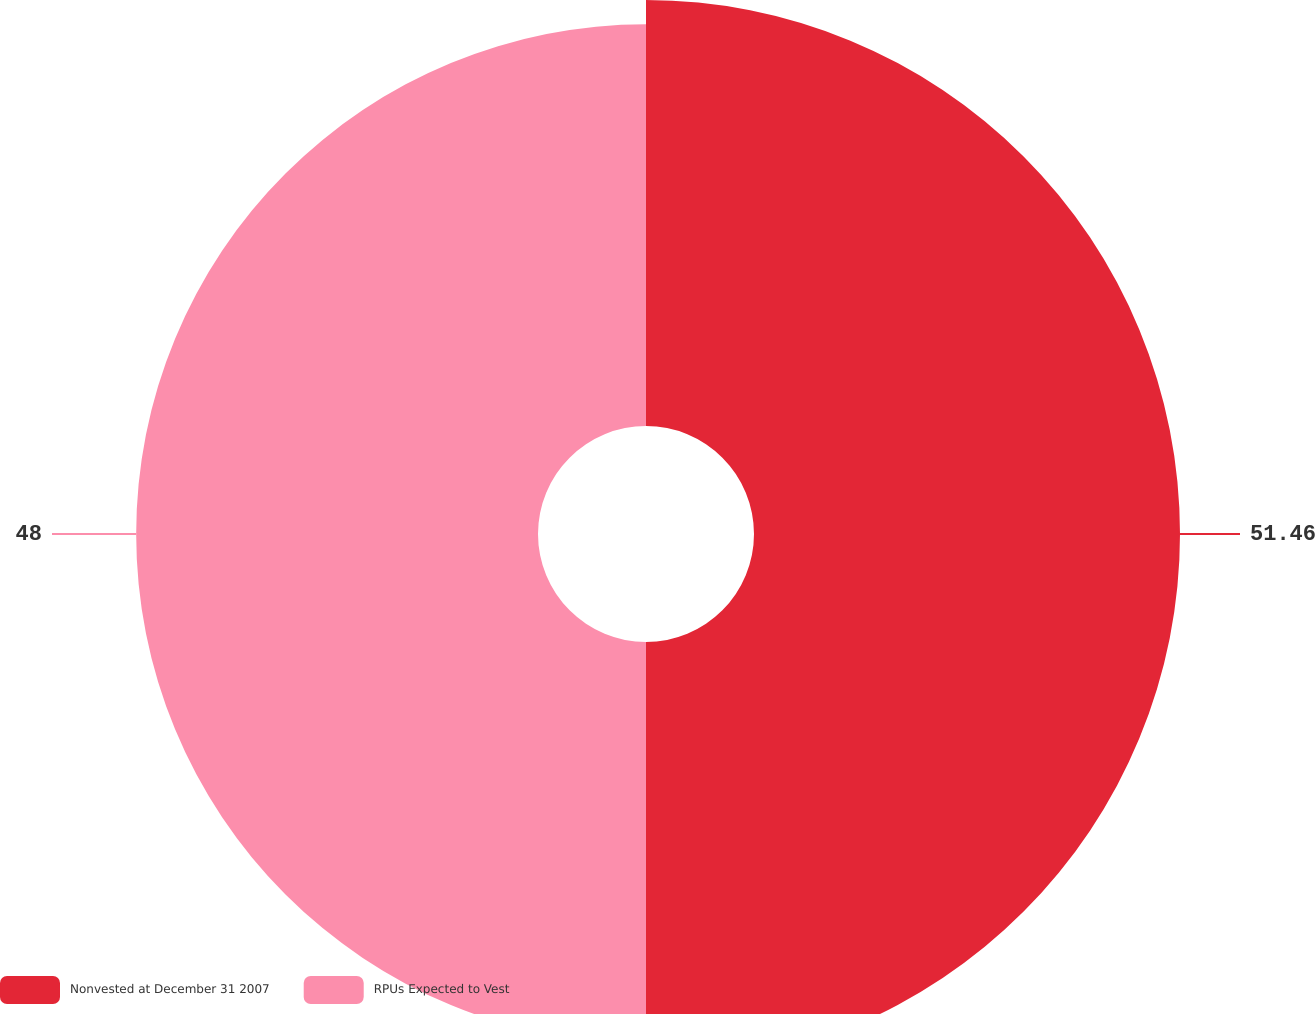Convert chart to OTSL. <chart><loc_0><loc_0><loc_500><loc_500><pie_chart><fcel>Nonvested at December 31 2007<fcel>RPUs Expected to Vest<nl><fcel>51.46%<fcel>48.54%<nl></chart> 